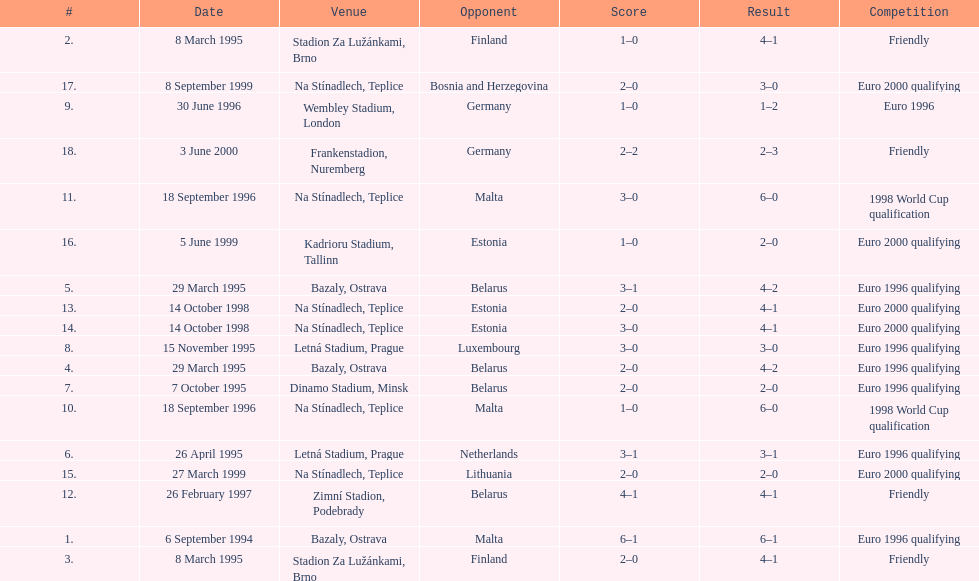Would you mind parsing the complete table? {'header': ['#', 'Date', 'Venue', 'Opponent', 'Score', 'Result', 'Competition'], 'rows': [['2.', '8 March 1995', 'Stadion Za Lužánkami, Brno', 'Finland', '1–0', '4–1', 'Friendly'], ['17.', '8 September 1999', 'Na Stínadlech, Teplice', 'Bosnia and Herzegovina', '2–0', '3–0', 'Euro 2000 qualifying'], ['9.', '30 June 1996', 'Wembley Stadium, London', 'Germany', '1–0', '1–2', 'Euro 1996'], ['18.', '3 June 2000', 'Frankenstadion, Nuremberg', 'Germany', '2–2', '2–3', 'Friendly'], ['11.', '18 September 1996', 'Na Stínadlech, Teplice', 'Malta', '3–0', '6–0', '1998 World Cup qualification'], ['16.', '5 June 1999', 'Kadrioru Stadium, Tallinn', 'Estonia', '1–0', '2–0', 'Euro 2000 qualifying'], ['5.', '29 March 1995', 'Bazaly, Ostrava', 'Belarus', '3–1', '4–2', 'Euro 1996 qualifying'], ['13.', '14 October 1998', 'Na Stínadlech, Teplice', 'Estonia', '2–0', '4–1', 'Euro 2000 qualifying'], ['14.', '14 October 1998', 'Na Stínadlech, Teplice', 'Estonia', '3–0', '4–1', 'Euro 2000 qualifying'], ['8.', '15 November 1995', 'Letná Stadium, Prague', 'Luxembourg', '3–0', '3–0', 'Euro 1996 qualifying'], ['4.', '29 March 1995', 'Bazaly, Ostrava', 'Belarus', '2–0', '4–2', 'Euro 1996 qualifying'], ['7.', '7 October 1995', 'Dinamo Stadium, Minsk', 'Belarus', '2–0', '2–0', 'Euro 1996 qualifying'], ['10.', '18 September 1996', 'Na Stínadlech, Teplice', 'Malta', '1–0', '6–0', '1998 World Cup qualification'], ['6.', '26 April 1995', 'Letná Stadium, Prague', 'Netherlands', '3–1', '3–1', 'Euro 1996 qualifying'], ['15.', '27 March 1999', 'Na Stínadlech, Teplice', 'Lithuania', '2–0', '2–0', 'Euro 2000 qualifying'], ['12.', '26 February 1997', 'Zimní Stadion, Podebrady', 'Belarus', '4–1', '4–1', 'Friendly'], ['1.', '6 September 1994', 'Bazaly, Ostrava', 'Malta', '6–1', '6–1', 'Euro 1996 qualifying'], ['3.', '8 March 1995', 'Stadion Za Lužánkami, Brno', 'Finland', '2–0', '4–1', 'Friendly']]} What venue is listed above wembley stadium, london? Letná Stadium, Prague. 